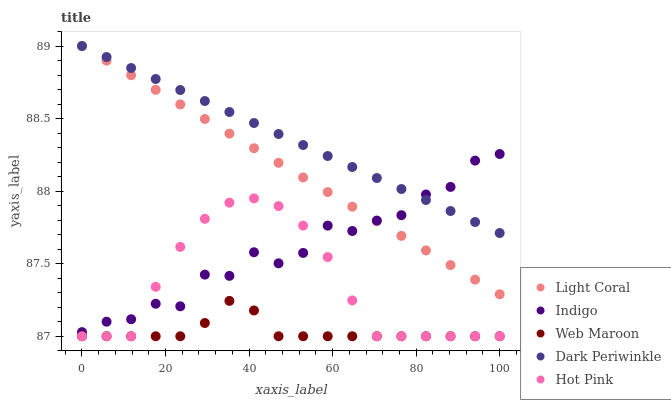Does Web Maroon have the minimum area under the curve?
Answer yes or no. Yes. Does Dark Periwinkle have the maximum area under the curve?
Answer yes or no. Yes. Does Hot Pink have the minimum area under the curve?
Answer yes or no. No. Does Hot Pink have the maximum area under the curve?
Answer yes or no. No. Is Dark Periwinkle the smoothest?
Answer yes or no. Yes. Is Indigo the roughest?
Answer yes or no. Yes. Is Web Maroon the smoothest?
Answer yes or no. No. Is Web Maroon the roughest?
Answer yes or no. No. Does Web Maroon have the lowest value?
Answer yes or no. Yes. Does Indigo have the lowest value?
Answer yes or no. No. Does Dark Periwinkle have the highest value?
Answer yes or no. Yes. Does Hot Pink have the highest value?
Answer yes or no. No. Is Web Maroon less than Light Coral?
Answer yes or no. Yes. Is Dark Periwinkle greater than Web Maroon?
Answer yes or no. Yes. Does Indigo intersect Hot Pink?
Answer yes or no. Yes. Is Indigo less than Hot Pink?
Answer yes or no. No. Is Indigo greater than Hot Pink?
Answer yes or no. No. Does Web Maroon intersect Light Coral?
Answer yes or no. No. 